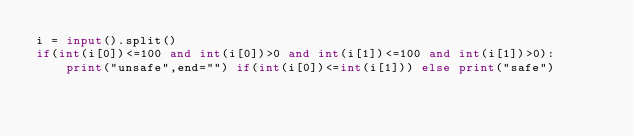Convert code to text. <code><loc_0><loc_0><loc_500><loc_500><_Python_>i = input().split()
if(int(i[0])<=100 and int(i[0])>0 and int(i[1])<=100 and int(i[1])>0):
    print("unsafe",end="") if(int(i[0])<=int(i[1])) else print("safe")</code> 